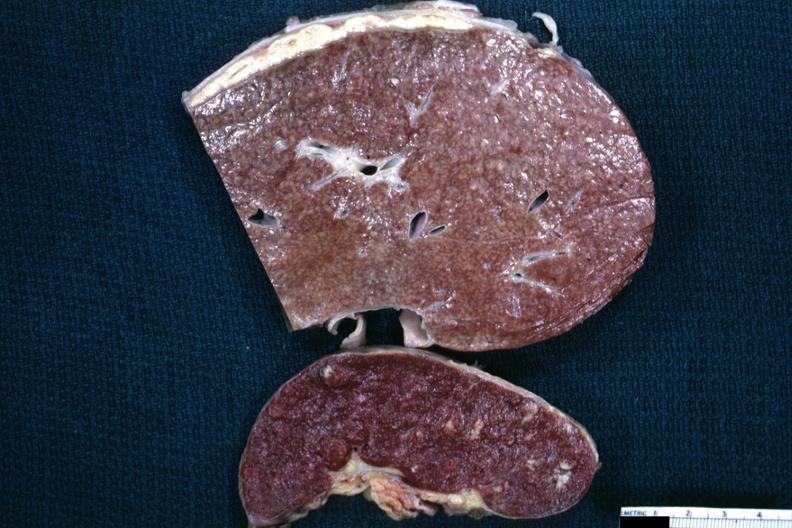what is present?
Answer the question using a single word or phrase. Abdomen 